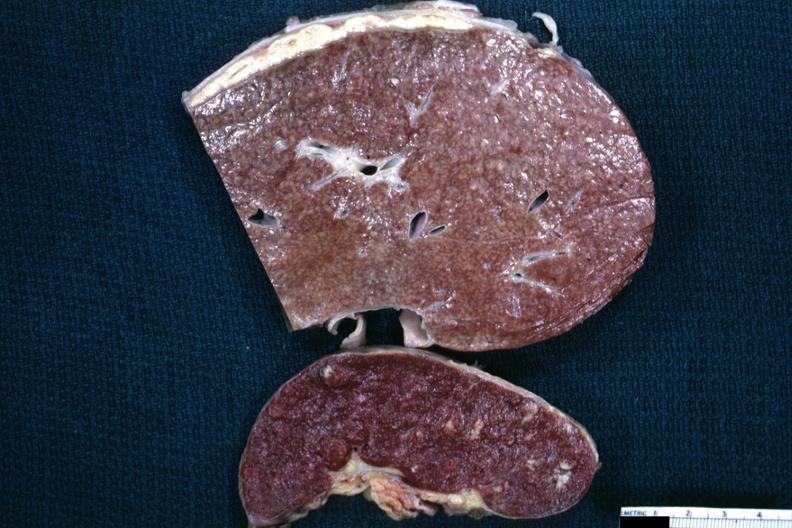what is present?
Answer the question using a single word or phrase. Abdomen 